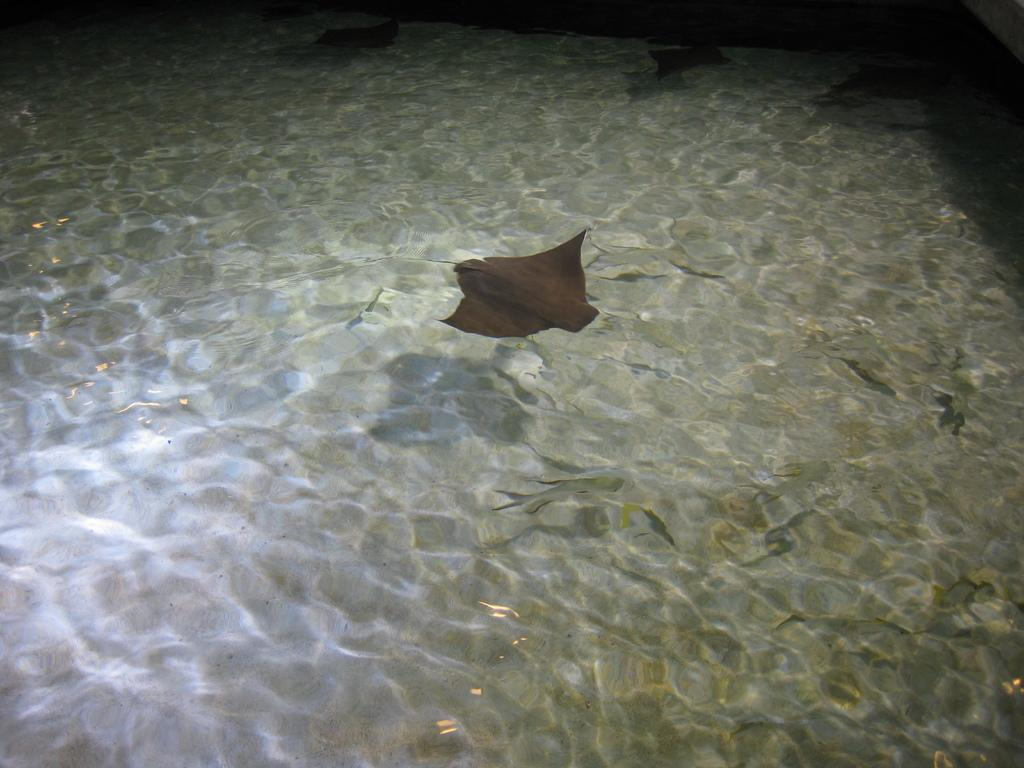What type of animal is the main subject of the image? There is a ray fish in the image. Are there any other animals present in the image? Yes, there are many other fishes in the image. Where are the fishes located? The fishes are in the water. What type of underwear is the ray fish wearing in the image? There is no underwear present in the image, as the ray fish is a marine animal and does not wear clothing. 